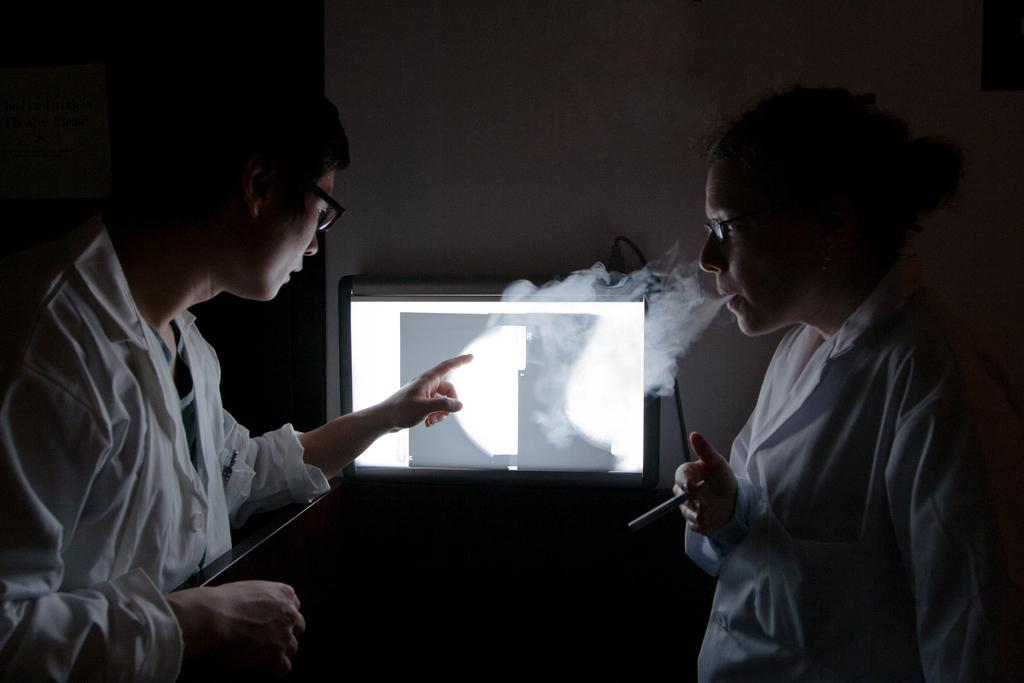How many people are in the image? There are two people standing in the image. Where are the people located? The people are standing on a path. What electronic device is visible in the image? There is a monitor visible in the image. What can be seen in the air in the image? There is smoke in the image. What type of structure is present in the image? There is a wall in the image. What type of secretary is visible in the image? There is no secretary present in the image. What tax-related information can be seen on the monitor in the image? There is no tax-related information visible on the monitor in the image. 